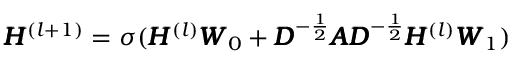Convert formula to latex. <formula><loc_0><loc_0><loc_500><loc_500>\pm b { H } ^ { ( l + 1 ) } = \sigma ( \pm b { H } ^ { ( l ) } \pm b { W } _ { 0 } + \pm b { D } ^ { - \frac { 1 } { 2 } } \pm b { A } \pm b { D } ^ { - \frac { 1 } { 2 } } \pm b { H } ^ { ( l ) } \pm b { W } _ { 1 } )</formula> 